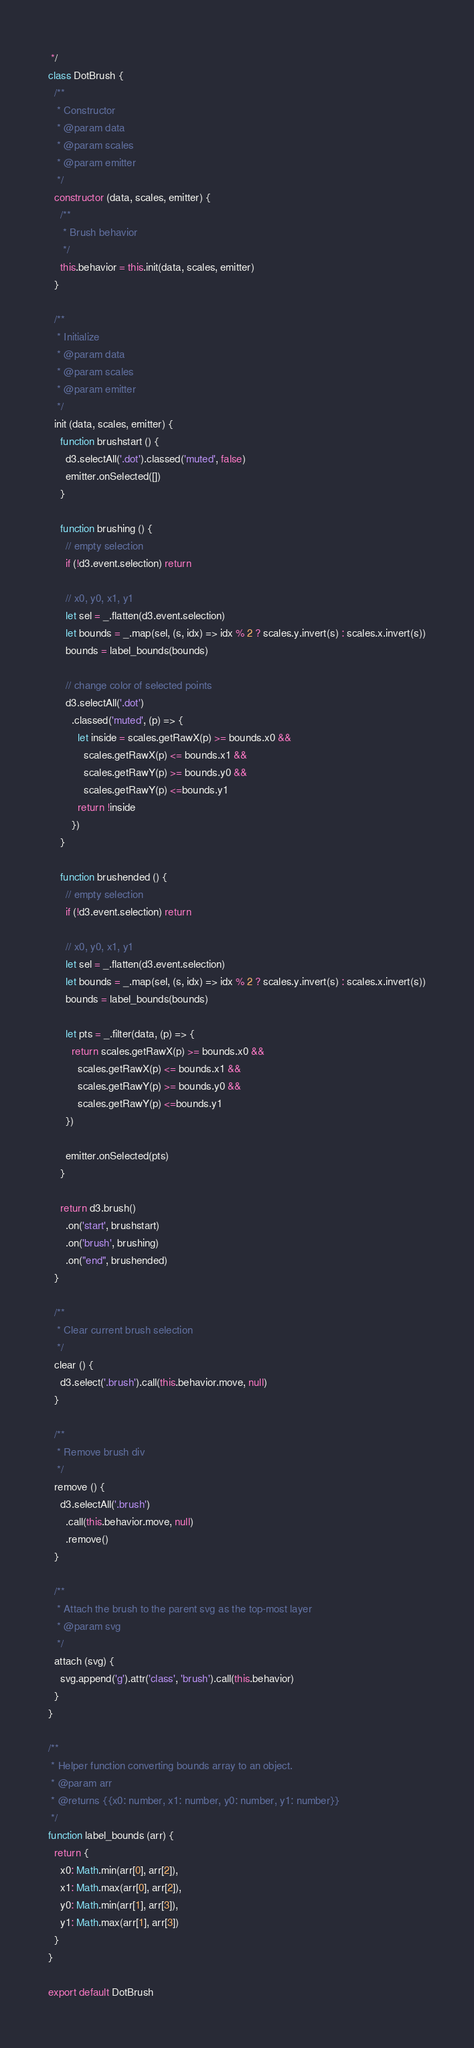Convert code to text. <code><loc_0><loc_0><loc_500><loc_500><_JavaScript_> */
class DotBrush {
  /**
   * Constructor
   * @param data
   * @param scales
   * @param emitter
   */
  constructor (data, scales, emitter) {
    /**
     * Brush behavior
     */
    this.behavior = this.init(data, scales, emitter)
  }

  /**
   * Initialize
   * @param data
   * @param scales
   * @param emitter
   */
  init (data, scales, emitter) {
    function brushstart () {
      d3.selectAll('.dot').classed('muted', false)
      emitter.onSelected([])
    }

    function brushing () {
      // empty selection
      if (!d3.event.selection) return

      // x0, y0, x1, y1
      let sel = _.flatten(d3.event.selection)
      let bounds = _.map(sel, (s, idx) => idx % 2 ? scales.y.invert(s) : scales.x.invert(s))
      bounds = label_bounds(bounds)

      // change color of selected points
      d3.selectAll('.dot')
        .classed('muted', (p) => {
          let inside = scales.getRawX(p) >= bounds.x0 &&
            scales.getRawX(p) <= bounds.x1 &&
            scales.getRawY(p) >= bounds.y0 &&
            scales.getRawY(p) <=bounds.y1
          return !inside
        })
    }

    function brushended () {
      // empty selection
      if (!d3.event.selection) return

      // x0, y0, x1, y1
      let sel = _.flatten(d3.event.selection)
      let bounds = _.map(sel, (s, idx) => idx % 2 ? scales.y.invert(s) : scales.x.invert(s))
      bounds = label_bounds(bounds)

      let pts = _.filter(data, (p) => {
        return scales.getRawX(p) >= bounds.x0 &&
          scales.getRawX(p) <= bounds.x1 &&
          scales.getRawY(p) >= bounds.y0 &&
          scales.getRawY(p) <=bounds.y1
      })

      emitter.onSelected(pts)
    }

    return d3.brush()
      .on('start', brushstart)
      .on('brush', brushing)
      .on("end", brushended)
  }

  /**
   * Clear current brush selection
   */
  clear () {
    d3.select('.brush').call(this.behavior.move, null)
  }

  /**
   * Remove brush div
   */
  remove () {
    d3.selectAll('.brush')
      .call(this.behavior.move, null)
      .remove()
  }

  /**
   * Attach the brush to the parent svg as the top-most layer
   * @param svg
   */
  attach (svg) {
    svg.append('g').attr('class', 'brush').call(this.behavior)
  }
}

/**
 * Helper function converting bounds array to an object.
 * @param arr
 * @returns {{x0: number, x1: number, y0: number, y1: number}}
 */
function label_bounds (arr) {
  return {
    x0: Math.min(arr[0], arr[2]),
    x1: Math.max(arr[0], arr[2]),
    y0: Math.min(arr[1], arr[3]),
    y1: Math.max(arr[1], arr[3])
  }
}

export default DotBrush
</code> 